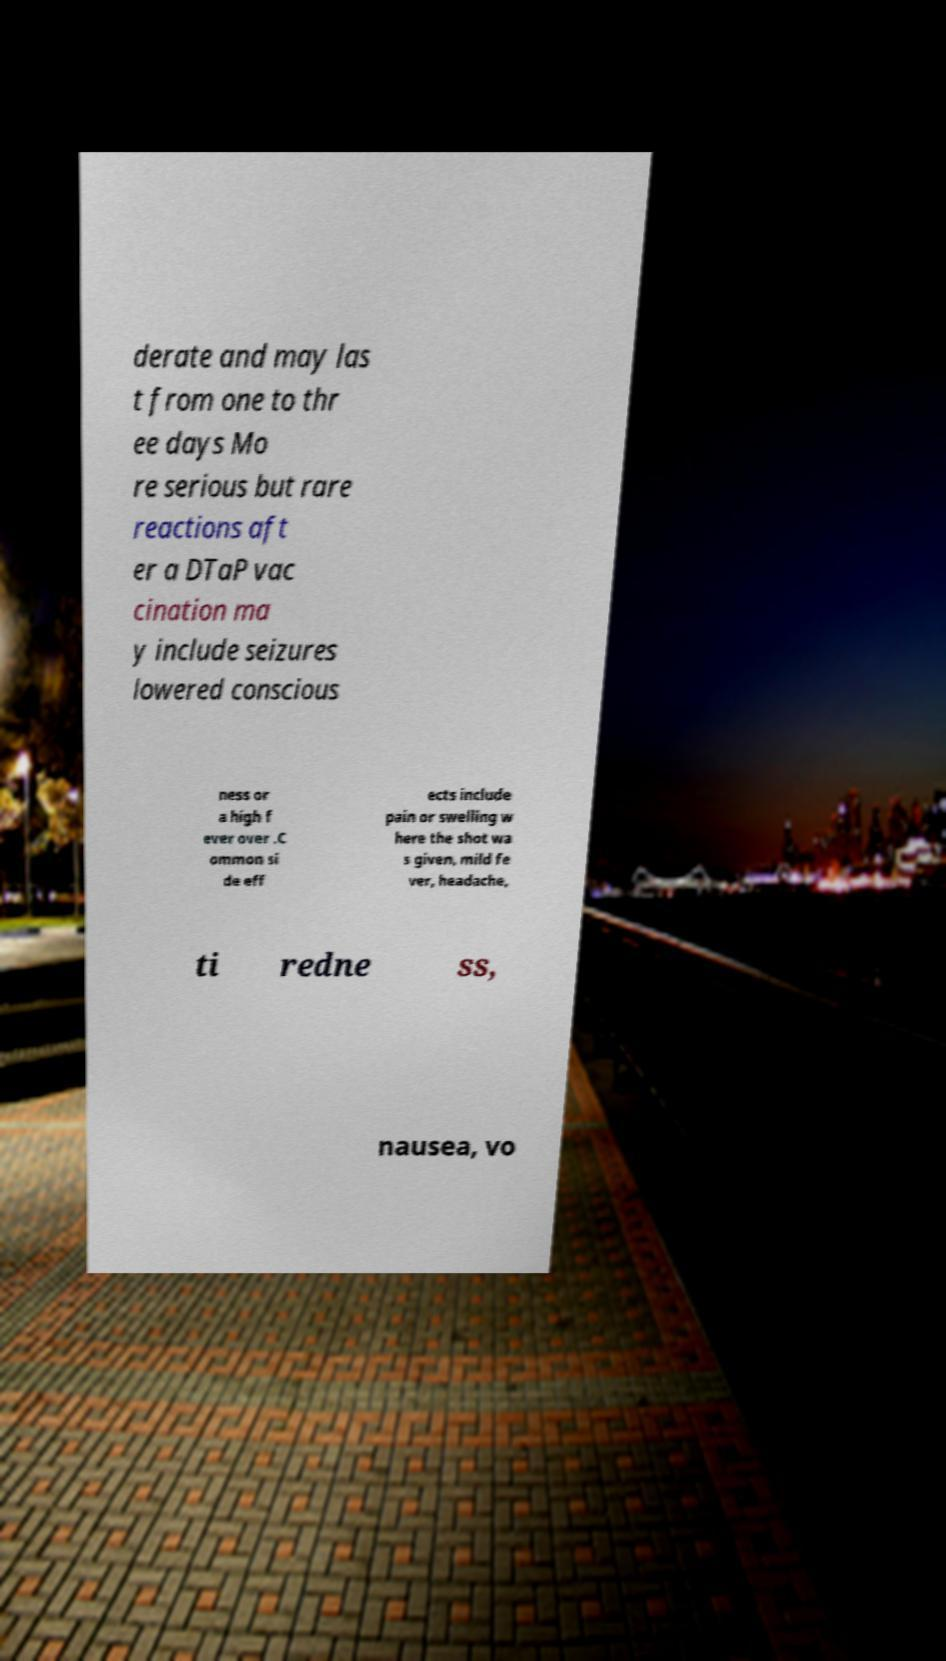There's text embedded in this image that I need extracted. Can you transcribe it verbatim? derate and may las t from one to thr ee days Mo re serious but rare reactions aft er a DTaP vac cination ma y include seizures lowered conscious ness or a high f ever over .C ommon si de eff ects include pain or swelling w here the shot wa s given, mild fe ver, headache, ti redne ss, nausea, vo 